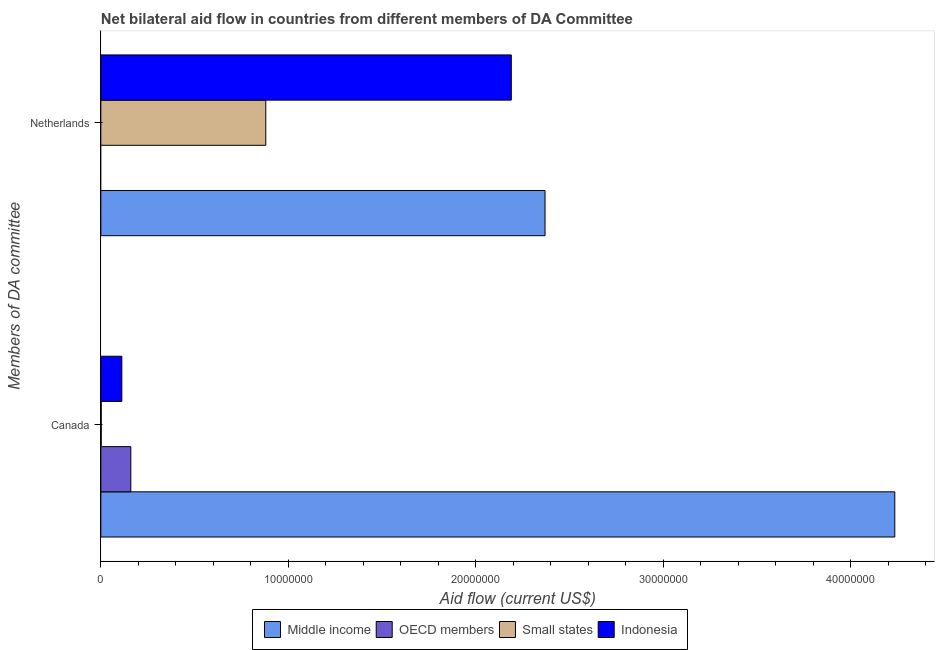How many different coloured bars are there?
Provide a succinct answer. 4. How many groups of bars are there?
Keep it short and to the point. 2. How many bars are there on the 2nd tick from the top?
Your answer should be very brief. 4. How many bars are there on the 2nd tick from the bottom?
Provide a succinct answer. 3. What is the amount of aid given by canada in Small states?
Your answer should be compact. 2.00e+04. Across all countries, what is the maximum amount of aid given by netherlands?
Your response must be concise. 2.37e+07. Across all countries, what is the minimum amount of aid given by netherlands?
Your response must be concise. 0. What is the total amount of aid given by canada in the graph?
Your response must be concise. 4.51e+07. What is the difference between the amount of aid given by canada in OECD members and that in Middle income?
Ensure brevity in your answer.  -4.08e+07. What is the difference between the amount of aid given by canada in Indonesia and the amount of aid given by netherlands in OECD members?
Your answer should be compact. 1.12e+06. What is the average amount of aid given by netherlands per country?
Offer a terse response. 1.36e+07. What is the difference between the amount of aid given by canada and amount of aid given by netherlands in Small states?
Your answer should be very brief. -8.78e+06. In how many countries, is the amount of aid given by canada greater than 10000000 US$?
Your answer should be compact. 1. What is the ratio of the amount of aid given by canada in OECD members to that in Indonesia?
Provide a short and direct response. 1.43. How many bars are there?
Provide a succinct answer. 7. How many countries are there in the graph?
Your answer should be very brief. 4. Are the values on the major ticks of X-axis written in scientific E-notation?
Provide a short and direct response. No. Does the graph contain grids?
Make the answer very short. No. How many legend labels are there?
Give a very brief answer. 4. How are the legend labels stacked?
Offer a very short reply. Horizontal. What is the title of the graph?
Provide a short and direct response. Net bilateral aid flow in countries from different members of DA Committee. Does "Isle of Man" appear as one of the legend labels in the graph?
Your response must be concise. No. What is the label or title of the Y-axis?
Your answer should be compact. Members of DA committee. What is the Aid flow (current US$) in Middle income in Canada?
Provide a succinct answer. 4.24e+07. What is the Aid flow (current US$) of OECD members in Canada?
Make the answer very short. 1.60e+06. What is the Aid flow (current US$) in Indonesia in Canada?
Ensure brevity in your answer.  1.12e+06. What is the Aid flow (current US$) of Middle income in Netherlands?
Ensure brevity in your answer.  2.37e+07. What is the Aid flow (current US$) of Small states in Netherlands?
Ensure brevity in your answer.  8.80e+06. What is the Aid flow (current US$) of Indonesia in Netherlands?
Your answer should be very brief. 2.19e+07. Across all Members of DA committee, what is the maximum Aid flow (current US$) in Middle income?
Provide a succinct answer. 4.24e+07. Across all Members of DA committee, what is the maximum Aid flow (current US$) in OECD members?
Provide a succinct answer. 1.60e+06. Across all Members of DA committee, what is the maximum Aid flow (current US$) of Small states?
Keep it short and to the point. 8.80e+06. Across all Members of DA committee, what is the maximum Aid flow (current US$) in Indonesia?
Provide a short and direct response. 2.19e+07. Across all Members of DA committee, what is the minimum Aid flow (current US$) in Middle income?
Your answer should be compact. 2.37e+07. Across all Members of DA committee, what is the minimum Aid flow (current US$) in Small states?
Keep it short and to the point. 2.00e+04. Across all Members of DA committee, what is the minimum Aid flow (current US$) in Indonesia?
Provide a short and direct response. 1.12e+06. What is the total Aid flow (current US$) in Middle income in the graph?
Provide a short and direct response. 6.61e+07. What is the total Aid flow (current US$) of OECD members in the graph?
Offer a terse response. 1.60e+06. What is the total Aid flow (current US$) of Small states in the graph?
Provide a short and direct response. 8.82e+06. What is the total Aid flow (current US$) in Indonesia in the graph?
Give a very brief answer. 2.30e+07. What is the difference between the Aid flow (current US$) in Middle income in Canada and that in Netherlands?
Your response must be concise. 1.87e+07. What is the difference between the Aid flow (current US$) of Small states in Canada and that in Netherlands?
Provide a short and direct response. -8.78e+06. What is the difference between the Aid flow (current US$) in Indonesia in Canada and that in Netherlands?
Ensure brevity in your answer.  -2.08e+07. What is the difference between the Aid flow (current US$) in Middle income in Canada and the Aid flow (current US$) in Small states in Netherlands?
Ensure brevity in your answer.  3.36e+07. What is the difference between the Aid flow (current US$) in Middle income in Canada and the Aid flow (current US$) in Indonesia in Netherlands?
Your answer should be compact. 2.05e+07. What is the difference between the Aid flow (current US$) of OECD members in Canada and the Aid flow (current US$) of Small states in Netherlands?
Your answer should be compact. -7.20e+06. What is the difference between the Aid flow (current US$) of OECD members in Canada and the Aid flow (current US$) of Indonesia in Netherlands?
Provide a short and direct response. -2.03e+07. What is the difference between the Aid flow (current US$) of Small states in Canada and the Aid flow (current US$) of Indonesia in Netherlands?
Offer a terse response. -2.19e+07. What is the average Aid flow (current US$) in Middle income per Members of DA committee?
Your answer should be very brief. 3.30e+07. What is the average Aid flow (current US$) of OECD members per Members of DA committee?
Give a very brief answer. 8.00e+05. What is the average Aid flow (current US$) in Small states per Members of DA committee?
Your answer should be compact. 4.41e+06. What is the average Aid flow (current US$) of Indonesia per Members of DA committee?
Make the answer very short. 1.15e+07. What is the difference between the Aid flow (current US$) of Middle income and Aid flow (current US$) of OECD members in Canada?
Your response must be concise. 4.08e+07. What is the difference between the Aid flow (current US$) in Middle income and Aid flow (current US$) in Small states in Canada?
Keep it short and to the point. 4.23e+07. What is the difference between the Aid flow (current US$) in Middle income and Aid flow (current US$) in Indonesia in Canada?
Provide a succinct answer. 4.12e+07. What is the difference between the Aid flow (current US$) of OECD members and Aid flow (current US$) of Small states in Canada?
Ensure brevity in your answer.  1.58e+06. What is the difference between the Aid flow (current US$) of OECD members and Aid flow (current US$) of Indonesia in Canada?
Your answer should be compact. 4.80e+05. What is the difference between the Aid flow (current US$) in Small states and Aid flow (current US$) in Indonesia in Canada?
Make the answer very short. -1.10e+06. What is the difference between the Aid flow (current US$) in Middle income and Aid flow (current US$) in Small states in Netherlands?
Ensure brevity in your answer.  1.49e+07. What is the difference between the Aid flow (current US$) of Middle income and Aid flow (current US$) of Indonesia in Netherlands?
Ensure brevity in your answer.  1.80e+06. What is the difference between the Aid flow (current US$) in Small states and Aid flow (current US$) in Indonesia in Netherlands?
Make the answer very short. -1.31e+07. What is the ratio of the Aid flow (current US$) of Middle income in Canada to that in Netherlands?
Make the answer very short. 1.79. What is the ratio of the Aid flow (current US$) in Small states in Canada to that in Netherlands?
Keep it short and to the point. 0. What is the ratio of the Aid flow (current US$) in Indonesia in Canada to that in Netherlands?
Give a very brief answer. 0.05. What is the difference between the highest and the second highest Aid flow (current US$) of Middle income?
Provide a succinct answer. 1.87e+07. What is the difference between the highest and the second highest Aid flow (current US$) in Small states?
Your answer should be very brief. 8.78e+06. What is the difference between the highest and the second highest Aid flow (current US$) of Indonesia?
Your answer should be compact. 2.08e+07. What is the difference between the highest and the lowest Aid flow (current US$) in Middle income?
Make the answer very short. 1.87e+07. What is the difference between the highest and the lowest Aid flow (current US$) in OECD members?
Keep it short and to the point. 1.60e+06. What is the difference between the highest and the lowest Aid flow (current US$) of Small states?
Ensure brevity in your answer.  8.78e+06. What is the difference between the highest and the lowest Aid flow (current US$) in Indonesia?
Provide a succinct answer. 2.08e+07. 